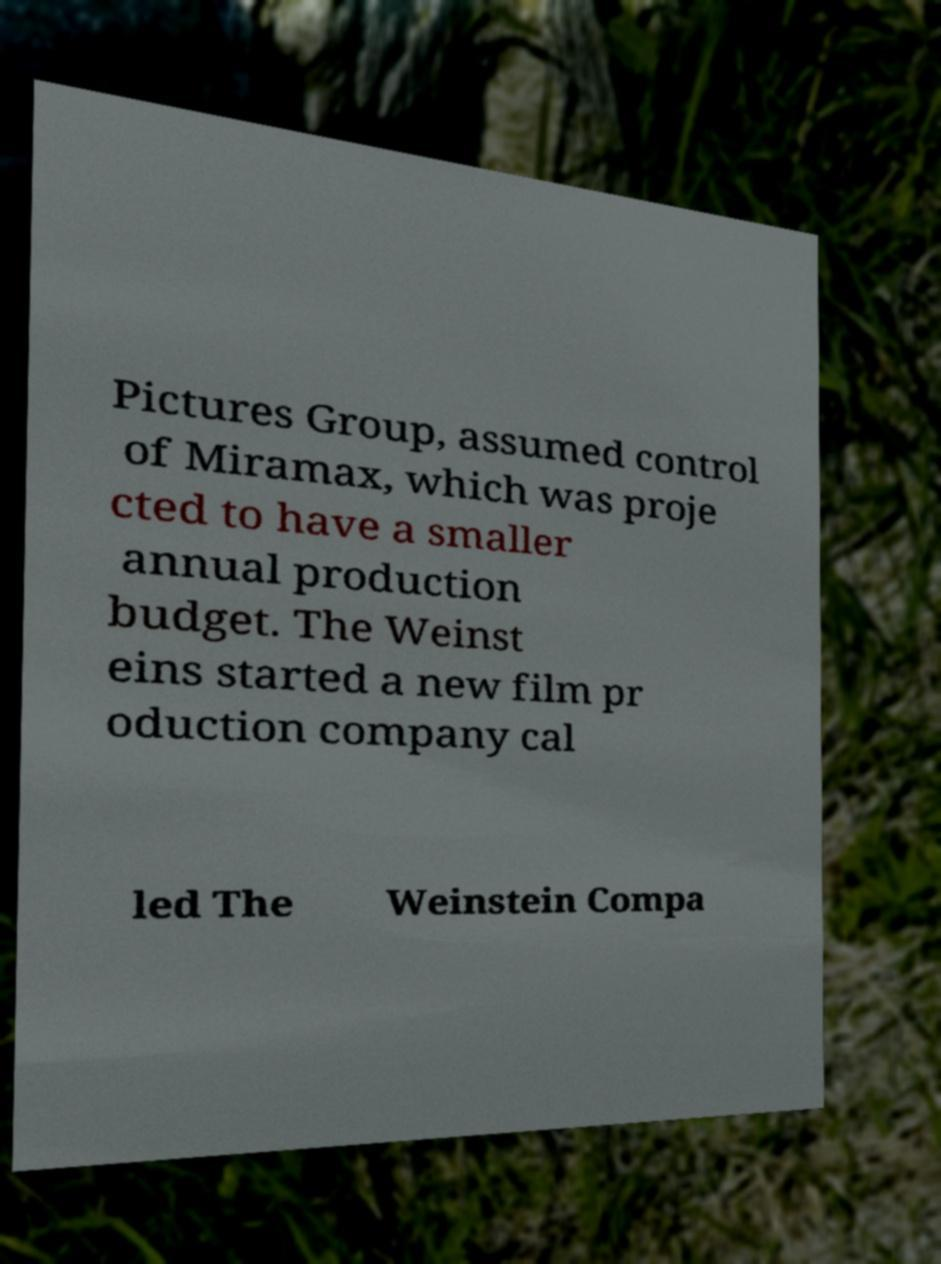What messages or text are displayed in this image? I need them in a readable, typed format. Pictures Group, assumed control of Miramax, which was proje cted to have a smaller annual production budget. The Weinst eins started a new film pr oduction company cal led The Weinstein Compa 